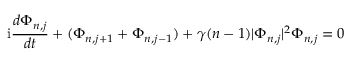Convert formula to latex. <formula><loc_0><loc_0><loc_500><loc_500>i { \frac { d \Phi _ { n , j } } { d t } } + ( \Phi _ { n , j + 1 } + \Phi _ { n , j - 1 } ) + \gamma ( n - 1 ) | \Phi _ { n , j } | ^ { 2 } \Phi _ { n , j } = 0</formula> 